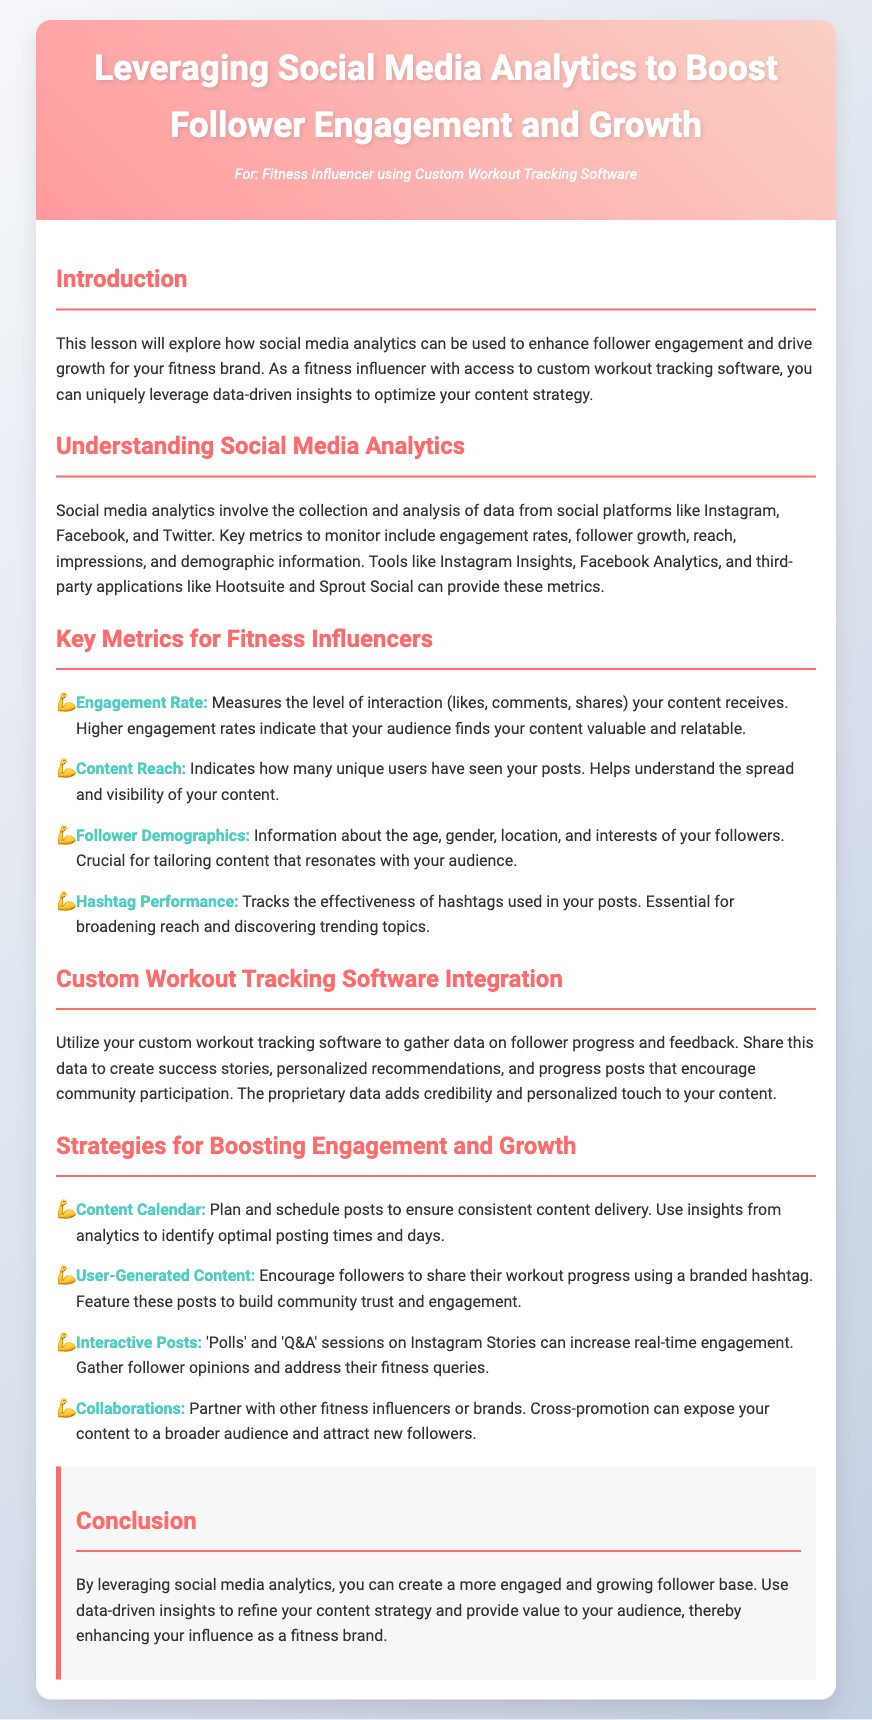what is the title of the lesson? The title of the lesson is located in the header of the document.
Answer: Leveraging Social Media Analytics to Boost Follower Engagement and Growth who is the target audience for this lesson? The target audience is mentioned in the persona section of the header.
Answer: Fitness Influencer using Custom Workout Tracking Software what is one key metric for fitness influencers mentioned in the document? The document lists various metrics in the section "Key Metrics for Fitness Influencers."
Answer: Engagement Rate what strategy is recommended for boosting engagement and growth? The document provides a list of strategies in the section "Strategies for Boosting Engagement and Growth."
Answer: Content Calendar which social media metrics are mentioned as important? The section "Understanding Social Media Analytics" lists important metrics.
Answer: Engagement rates, follower growth, reach, impressions, and demographic information what type of content encourages community participation according to the document? The document specifies content types that encourage participation in the section "Custom Workout Tracking Software Integration."
Answer: Progress posts how can user-generated content boost engagement? The document explains in "Strategies for Boosting Engagement and Growth" how followers can engage through shared content.
Answer: Builds community trust which tool is mentioned for analyzing social media metrics? The document lists tools under "Understanding Social Media Analytics."
Answer: Instagram Insights what does the conclusion suggest about using data-driven insights? The conclusion emphasizes the benefits of leveraging analytics for content strategy.
Answer: Enhance your influence as a fitness brand 